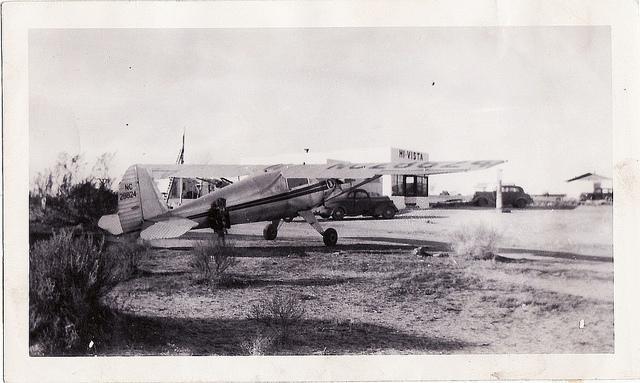How many wings does the plane have?
Give a very brief answer. 2. 